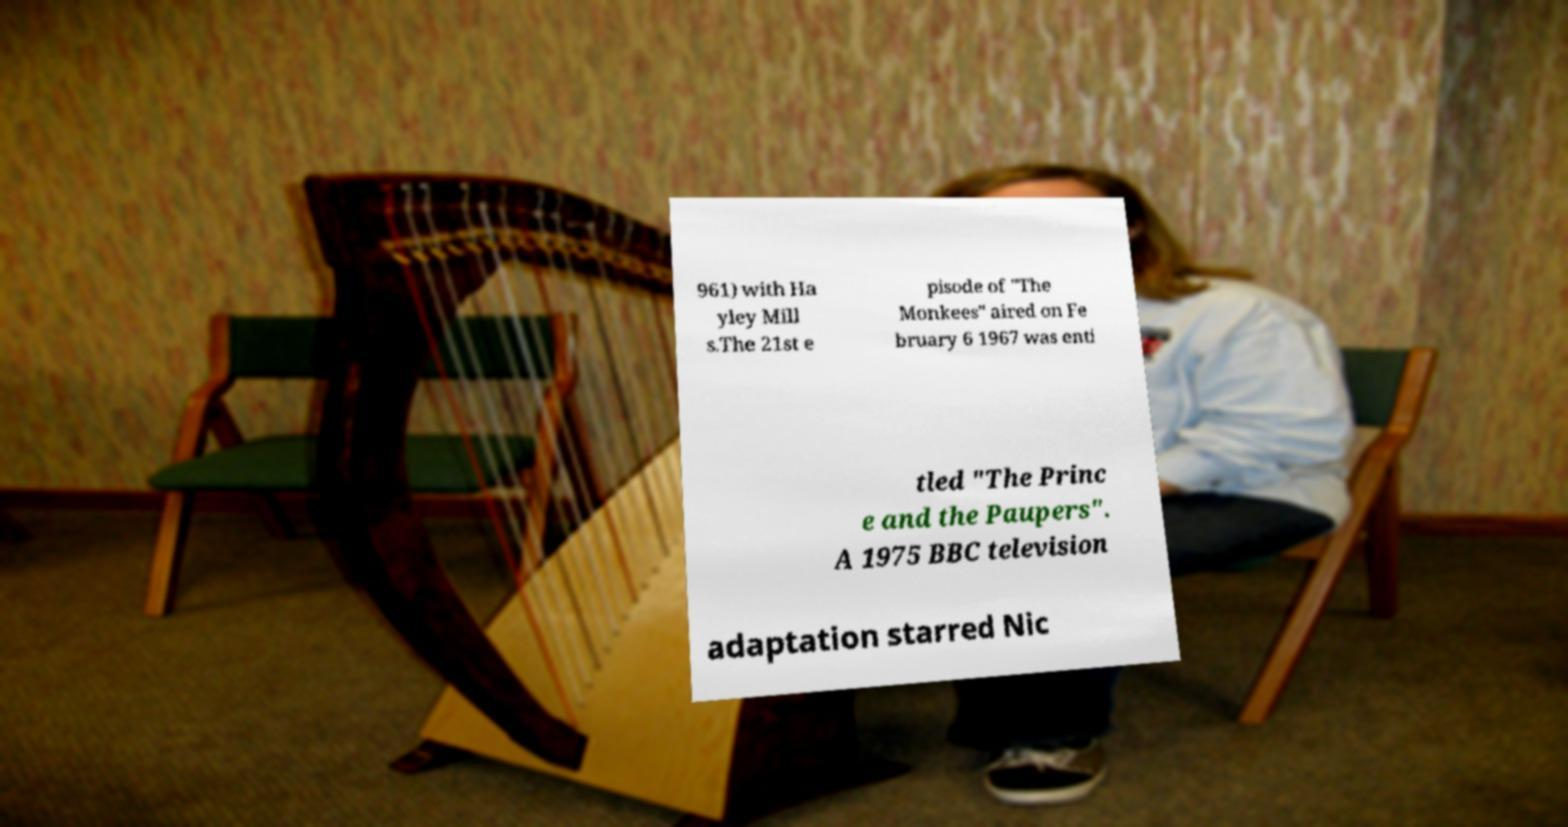Could you assist in decoding the text presented in this image and type it out clearly? 961) with Ha yley Mill s.The 21st e pisode of "The Monkees" aired on Fe bruary 6 1967 was enti tled "The Princ e and the Paupers". A 1975 BBC television adaptation starred Nic 